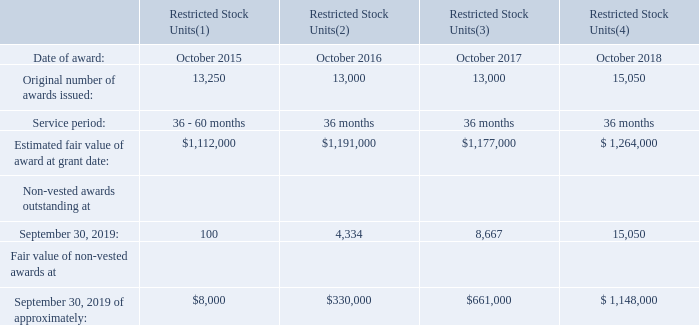Restricted Stock Units
At September 2019, the Compensation Committee of the Board of Directors had authorized and approved the following restricted stock unit awards to members of the Company’s management team pursuant to the provisions of the Company’s Omnibus Plans: At September 2019, the Compensation Committee of the Board of Directors had authorized and approved the following restricted stock unit awards to members of the Company’s management team pursuant to the provisions of the Company’s Omnibus Plans:
(1) 13,150 of the restricted stock units were vested as of September 2019. The remaining 100 restricted stock units
will vest in equal amounts in October 2019 and October 2020.
(2) 8,666 of the restricted stock units were vested as of September 2019. The remaining 4,334 restricted stock units
will vest in October 2019.
(3) 4,333 of the restricted stock units were vested as of September 2019. 4,333 restricted stock units will vest in
October 2019 and 4,334 will vest in October 2020.
(4) The 15,050 restricted stock units will vest in equal amounts in October 2019, October 2020, and October 2021.
There is no direct cost to the recipients of the restricted stock units, except for any applicable taxes. The recipients of the restricted stock units are entitled to the customary adjustments in the event of stock splits, stock dividends, and certain other distributions on the Company’s common stock. All cash dividends and/or distributions payable to restricted stock recipients will be held in escrow until all the conditions of vesting have been met.
The restricted stock units provide that the recipients can elect, at their option, to receive either common stock in the
Company, or a cash settlement based upon the closing price of the Company’s shares, at the time of vesting. Based on
these award provisions, the compensation expense recorded in the Company’s Statement of Operations reflects the
straight-line amortized fair value based on the liability method under “ASC 718 – Compensation – Stock Compensation”.
Net income before income taxes included compensation expense related to the amortization of the Company’s restricted stock unit awards of approximately $1.2 million during both fiscal 2019 and fiscal 2018. These amounts were recorded as accrued expenses in the Company’s Consolidated Balance Sheet at both September 2019 and September 2018. The tax benefit related to this compensation expense was approximately $0.3 million in both fiscal 2019 and fiscal 2018. The total intrinsic value of restricted stock units vested during fiscal 2019 and fiscal 2018 was approximately $1.1 million and $1.2 million, respectively.
How many restricted stock units awarded in October 2015 and 2016 were vested respectively as of September 2019? 13,150, 8,666. How many restricted stock units awarded in October 2017 were vested as of September 2019? 4,333. What is the total intrinsic value of restricted stock units vested during fiscal 2019 and fiscal 2018 respectively? $1.1 million, $1.2 million. What is the percentage change in the number of restricted stock units originally issued in October 2015 and 2016?
Answer scale should be: percent. (13,000 -13,250)/13,250 
Answer: -1.89. What is the percentage change in the number of restricted stock units originally issued in October 2017 and 2018?
Answer scale should be: percent. (15,050 - 13,000)/13,000 
Answer: 15.77. What is the total number of restricted stock units vested as of September 2019? (13,150 + 8,666 + 4,333)
Answer: 26149. 